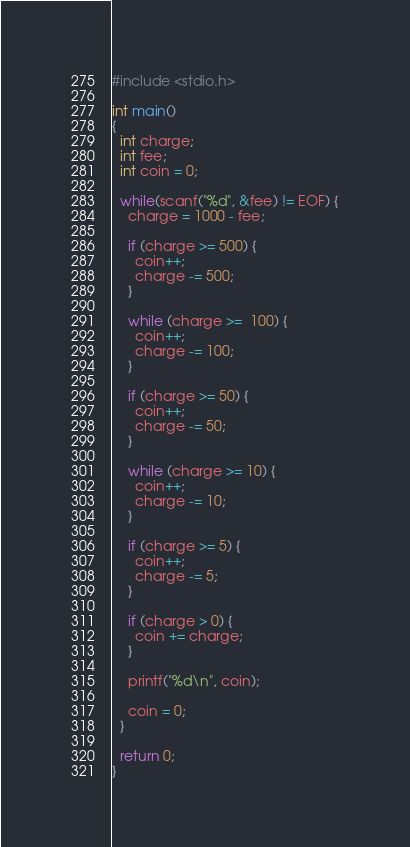<code> <loc_0><loc_0><loc_500><loc_500><_C_>#include <stdio.h>

int main()
{
  int charge;
  int fee;
  int coin = 0;

  while(scanf("%d", &fee) != EOF) {
    charge = 1000 - fee;

    if (charge >= 500) {
      coin++;
      charge -= 500;
    }

    while (charge >=  100) {
      coin++;
      charge -= 100;
    }

    if (charge >= 50) {
      coin++;
      charge -= 50;
    }

    while (charge >= 10) {
      coin++;
      charge -= 10;
    }

    if (charge >= 5) {
      coin++;
      charge -= 5;
    }

    if (charge > 0) {
      coin += charge;
    }

    printf("%d\n", coin);

    coin = 0;
  }

  return 0;
}</code> 